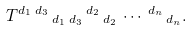Convert formula to latex. <formula><loc_0><loc_0><loc_500><loc_500>T ^ { d _ { 1 } } \, ^ { d _ { 3 } } \, _ { d _ { 1 } } \, _ { d _ { 3 } } \, ^ { d _ { 2 } } \, _ { d _ { 2 } } \, \cdots \, ^ { d _ { n } } \, _ { d _ { n } } .</formula> 